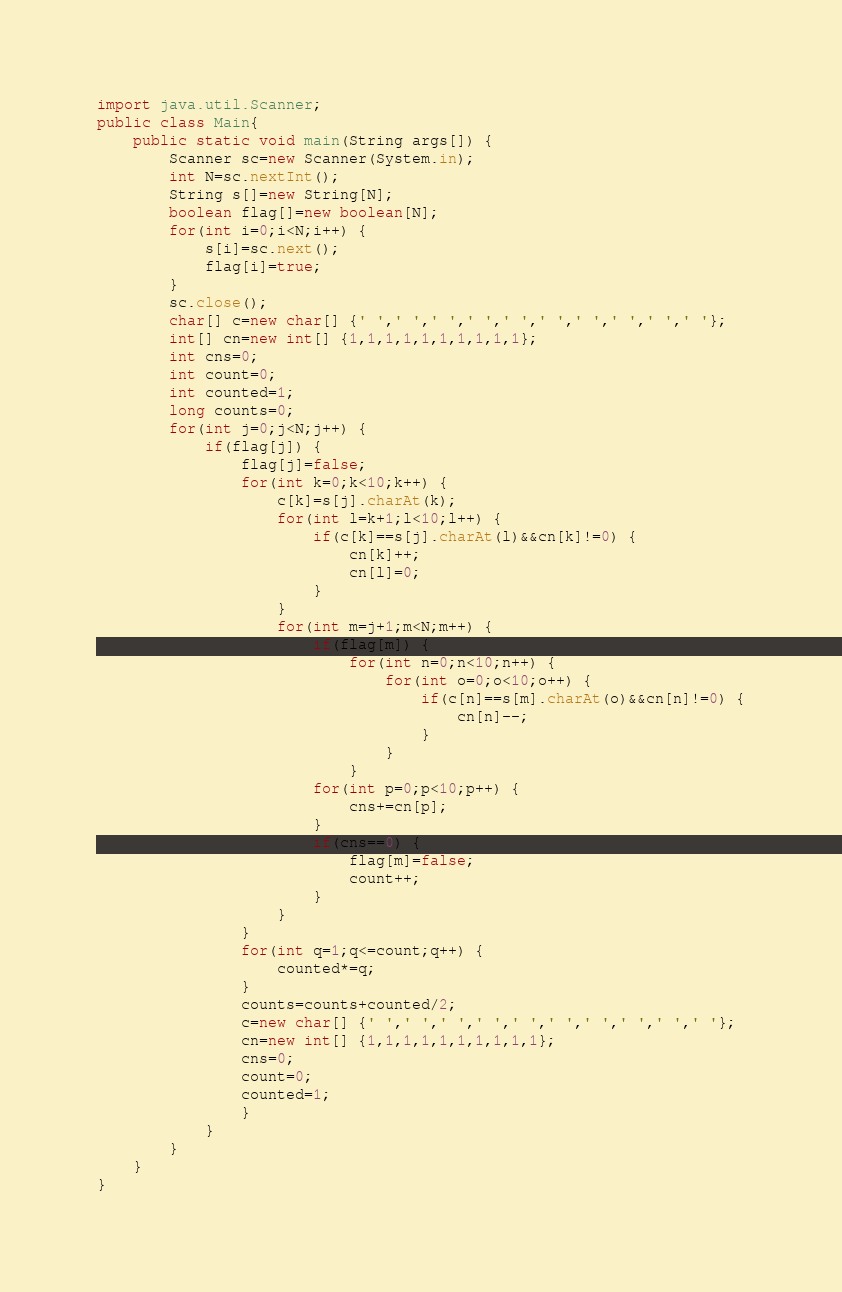Convert code to text. <code><loc_0><loc_0><loc_500><loc_500><_Java_>import java.util.Scanner;
public class Main{
	public static void main(String args[]) {
		Scanner sc=new Scanner(System.in);
		int N=sc.nextInt();
		String s[]=new String[N];
		boolean flag[]=new boolean[N];
		for(int i=0;i<N;i++) {
			s[i]=sc.next();
			flag[i]=true;
		}
		sc.close();
		char[] c=new char[] {' ',' ',' ',' ',' ',' ',' ',' ',' ',' '};
		int[] cn=new int[] {1,1,1,1,1,1,1,1,1,1};
		int cns=0;
		int count=0;
		int counted=1;
		long counts=0;
		for(int j=0;j<N;j++) {
			if(flag[j]) {
				flag[j]=false;
				for(int k=0;k<10;k++) {
					c[k]=s[j].charAt(k);
					for(int l=k+1;l<10;l++) {
						if(c[k]==s[j].charAt(l)&&cn[k]!=0) {
							cn[k]++;
							cn[l]=0;
						}
					}
					for(int m=j+1;m<N;m++) {
						if(flag[m]) {
							for(int n=0;n<10;n++) {
								for(int o=0;o<10;o++) {
									if(c[n]==s[m].charAt(o)&&cn[n]!=0) {
										cn[n]--;
									}
								}
							}
						for(int p=0;p<10;p++) {
							cns+=cn[p];
						}
						if(cns==0) {
							flag[m]=false;
							count++;
						}
					}
				}
				for(int q=1;q<=count;q++) {
					counted*=q;
				}
				counts=counts+counted/2;
				c=new char[] {' ',' ',' ',' ',' ',' ',' ',' ',' ',' '};
				cn=new int[] {1,1,1,1,1,1,1,1,1,1};
				cns=0;
				count=0;
				counted=1;
				}
			}
		}
	}
}</code> 